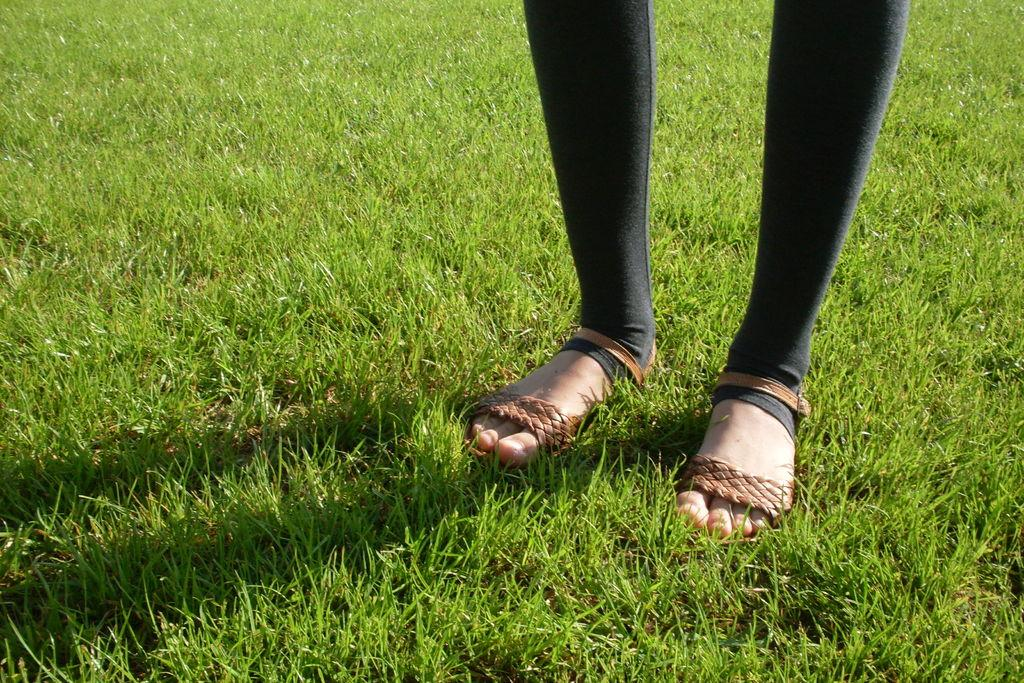What part of a person's body is visible in the image? There is a person's leg in the image. What type of terrain is depicted in the image? There is grass on the ground in the image. Reasoning: Let's think step by identifying the main subjects and objects in the image based on the provided facts. We then formulate questions that focus on the location and characteristics of these subjects and objects, ensuring that each question can be answered definitively with the information given. We avoid yes/no questions and ensure that the language is simple and clear. Absurd Question/Answer: How many ladybugs can be seen on the person's leg in the image? There are no ladybugs present in the image; it only shows a person's leg and grass on the ground. What type of container is used for washing in the image? There is no basin or any container for washing present in the image. How many parent figures are present in the image? There are no parent figures present in the image; it only shows a person's leg and grass on the ground. 